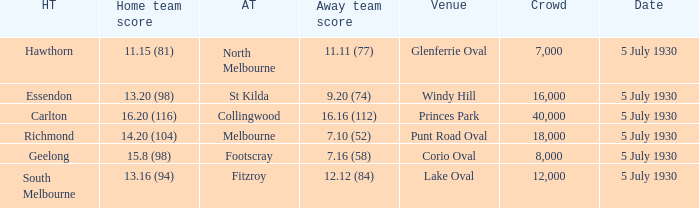Who is the away side at corio oval? Footscray. 